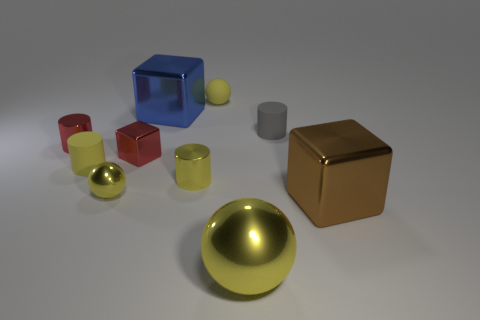Subtract all large brown metallic blocks. How many blocks are left? 2 Subtract all brown cubes. How many cubes are left? 2 Subtract 1 spheres. How many spheres are left? 2 Subtract all cylinders. How many objects are left? 6 Subtract all purple blocks. Subtract all cyan spheres. How many blocks are left? 3 Subtract all brown cylinders. How many blue blocks are left? 1 Subtract all blue matte cubes. Subtract all yellow matte spheres. How many objects are left? 9 Add 4 red cubes. How many red cubes are left? 5 Add 2 yellow cylinders. How many yellow cylinders exist? 4 Subtract 0 green cylinders. How many objects are left? 10 